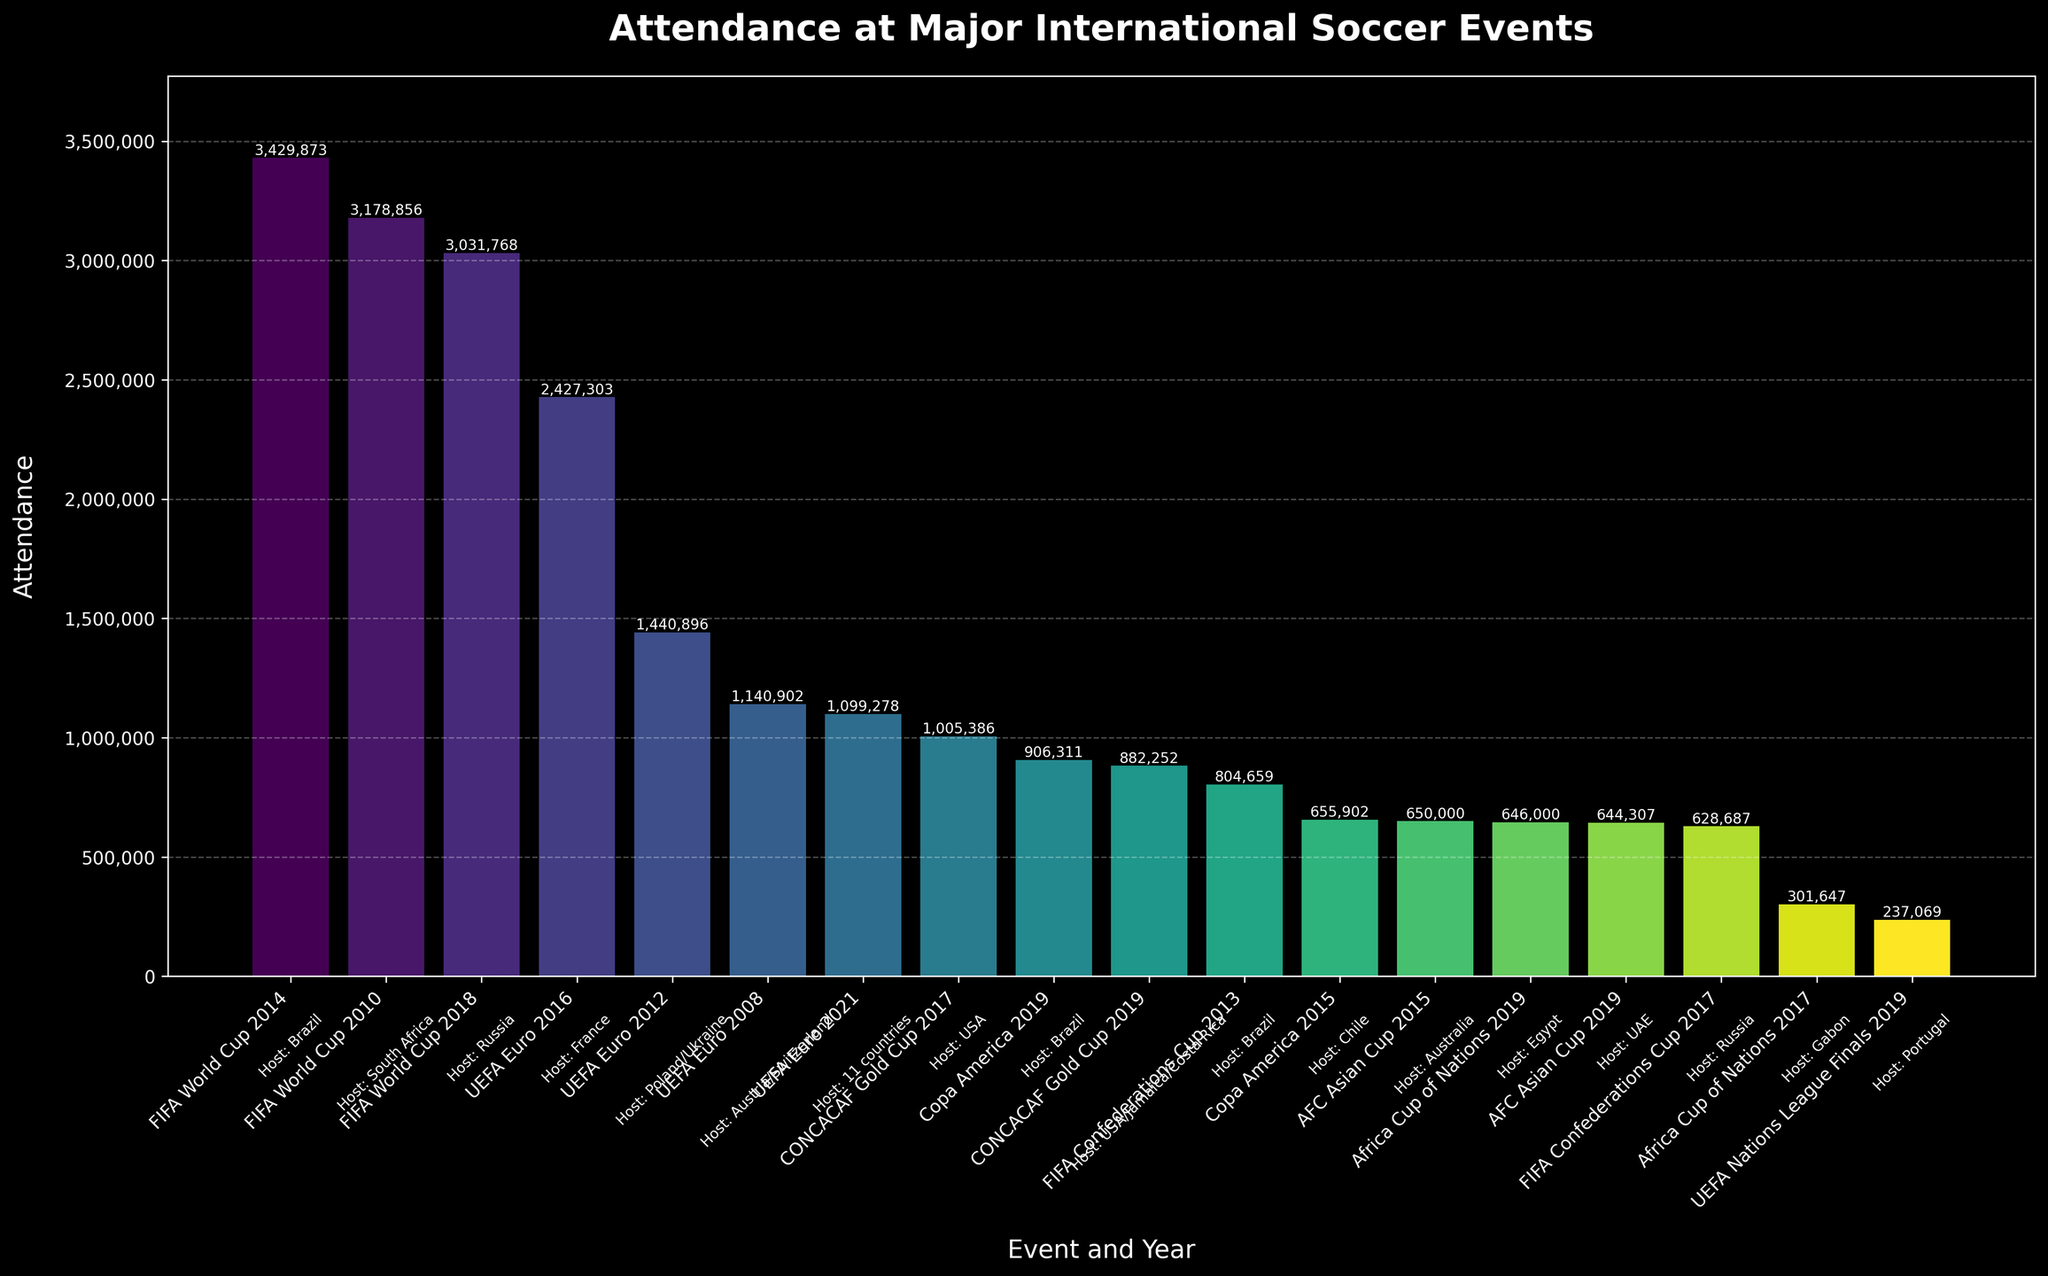What's the total attendance for all FIFA World Cup events? Identify the attendance figures for all FIFA World Cup events: 3,031,768 (2018), 3,429,873 (2014), 3,178,856 (2010). Sum these figures to get the total attendance. 3,031,768 + 3,429,873 + 3,178,856 = 9,640,497
Answer: 9,640,497 Which event had the highest attendance? Look for the bar that reaches the highest point on the y-axis, which corresponds to the FIFA World Cup in Brazil (2014) with an attendance of 3,429,873
Answer: FIFA World Cup 2014 What is the average attendance for UEFA Euro events? Identify the attendance for all UEFA Euro events: 2,427,303 (2016), 1,440,896 (2012), 1,140,902 (2008), 1,099,278 (2021). Sum these values and divide by the number of events (4). (2,427,303 + 1,440,896 + 1,140,902 + 1,099,278) / 4 = 6,108,379 / 4
Answer: 1,527,095 Which event had a higher attendance: Copa America 2019 or Africa Cup of Nations 2019? Compare the heights of the bars for Copa America 2019 and Africa Cup of Nations 2019. Copa America 2019 had 906,311 attendees, while Africa Cup of Nations 2019 had 646,000. 906,311 is greater than 646,000
Answer: Copa America 2019 What is the difference in attendance between the UEFA Euro 2016 and the UEFA Nations League Finals 2019? Find the attendance numbers: UEFA Euro 2016 (2,427,303) and UEFA Nations League Finals 2019 (237,069). Subtract the smaller from the larger. 2,427,303 - 237,069
Answer: 2,190,234 Which events were hosted by Brazil, and what were their attendance figures? Identify the events hosted by Brazil: Copa America 2019 (906,311) and FIFA Confederations Cup 2013 (804,659), and FIFA World Cup 2014 (3,429,873). List the corresponding attendance figures.
Answer: Copa America 2019: 906,311; FIFA Confederations Cup 2013: 804,659; FIFA World Cup 2014: 3,429,873 What is the median attendance figure across all events? List all the attendance figures in numerical order: 237,069, 301,647, 628,687, 644,307, 646,000, 650,000, 655,902, 804,659, 882,252, 906,311, 1,099,278, 1,140,902, 1,440,896, 2,427,303, 3,031,768, 3,178,856, 3,429,873. Since there are 17 events, the median is the 9th value in this ordered list.
Answer: 882,252 